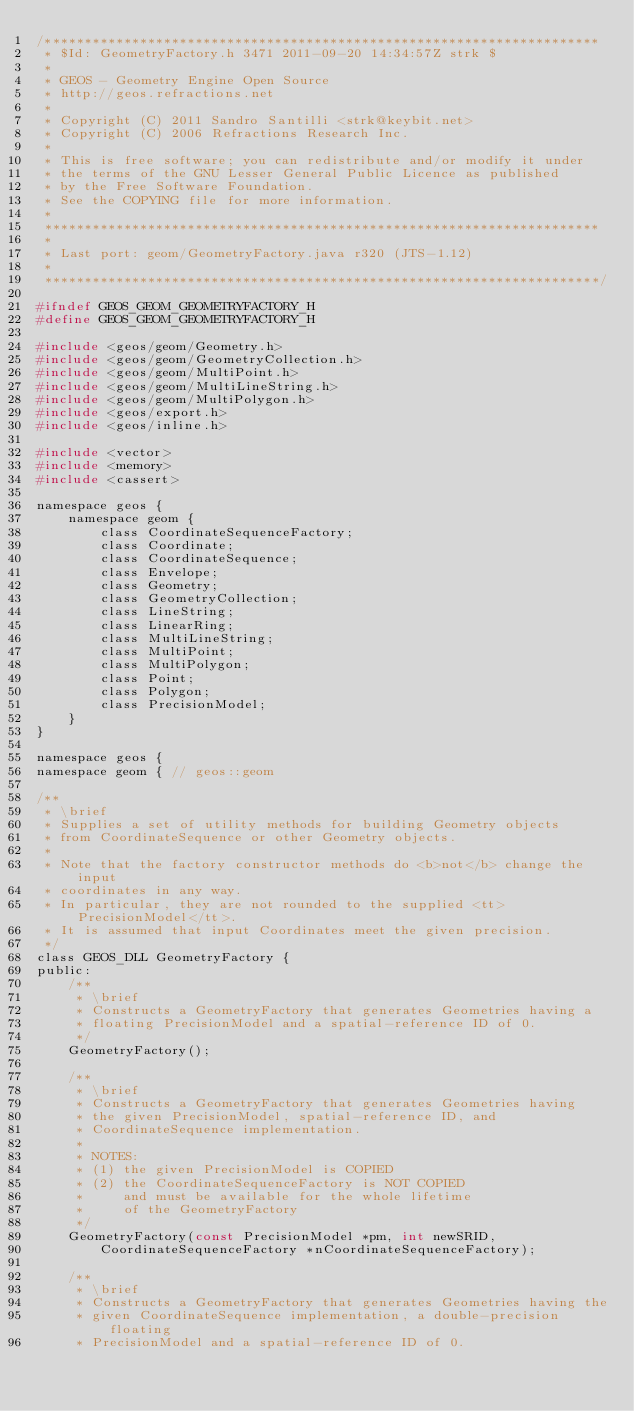Convert code to text. <code><loc_0><loc_0><loc_500><loc_500><_C_>/**********************************************************************
 * $Id: GeometryFactory.h 3471 2011-09-20 14:34:57Z strk $
 *
 * GEOS - Geometry Engine Open Source
 * http://geos.refractions.net
 *
 * Copyright (C) 2011 Sandro Santilli <strk@keybit.net>
 * Copyright (C) 2006 Refractions Research Inc.
 *
 * This is free software; you can redistribute and/or modify it under
 * the terms of the GNU Lesser General Public Licence as published
 * by the Free Software Foundation. 
 * See the COPYING file for more information.
 *
 **********************************************************************
 *
 * Last port: geom/GeometryFactory.java r320 (JTS-1.12)
 *
 **********************************************************************/

#ifndef GEOS_GEOM_GEOMETRYFACTORY_H
#define GEOS_GEOM_GEOMETRYFACTORY_H

#include <geos/geom/Geometry.h>
#include <geos/geom/GeometryCollection.h>
#include <geos/geom/MultiPoint.h>
#include <geos/geom/MultiLineString.h>
#include <geos/geom/MultiPolygon.h>
#include <geos/export.h>
#include <geos/inline.h>

#include <vector>
#include <memory>
#include <cassert>

namespace geos {
	namespace geom { 
		class CoordinateSequenceFactory;
		class Coordinate;
		class CoordinateSequence;
		class Envelope;
		class Geometry;
		class GeometryCollection;
		class LineString;
		class LinearRing;
		class MultiLineString;
		class MultiPoint;
		class MultiPolygon;
		class Point;
		class Polygon;
		class PrecisionModel;
	}
}

namespace geos {
namespace geom { // geos::geom

/**
 * \brief
 * Supplies a set of utility methods for building Geometry objects
 * from CoordinateSequence or other Geometry objects.
 *
 * Note that the factory constructor methods do <b>not</b> change the input
 * coordinates in any way.
 * In particular, they are not rounded to the supplied <tt>PrecisionModel</tt>.
 * It is assumed that input Coordinates meet the given precision.
 */
class GEOS_DLL GeometryFactory {
public:
	/**
	 * \brief 
	 * Constructs a GeometryFactory that generates Geometries having a
	 * floating PrecisionModel and a spatial-reference ID of 0.
	 */
	GeometryFactory();

	/**
	 * \brief
	 * Constructs a GeometryFactory that generates Geometries having
	 * the given PrecisionModel, spatial-reference ID, and
	 * CoordinateSequence implementation.
	 *
	 * NOTES:
	 * (1) the given PrecisionModel is COPIED
	 * (2) the CoordinateSequenceFactory is NOT COPIED
	 *     and must be available for the whole lifetime
	 *     of the GeometryFactory
	 */
	GeometryFactory(const PrecisionModel *pm, int newSRID,
		CoordinateSequenceFactory *nCoordinateSequenceFactory);

	/**
	 * \brief
	 * Constructs a GeometryFactory that generates Geometries having the
	 * given CoordinateSequence implementation, a double-precision floating
	 * PrecisionModel and a spatial-reference ID of 0.</code> 